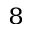<formula> <loc_0><loc_0><loc_500><loc_500>^ { 8 }</formula> 